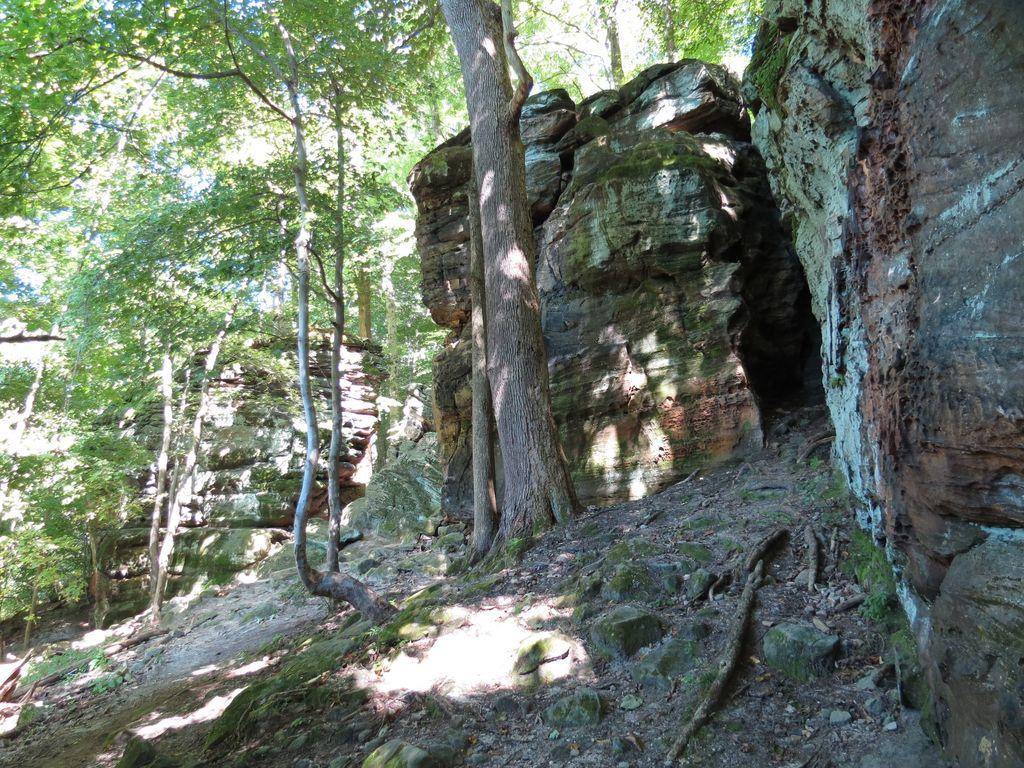What type of natural elements can be seen in the image? There are rocks in the image. What can be seen in the background of the image? There are trees and the sky visible in the background of the image. What type of jelly can be seen on the rocks in the image? There is no jelly present on the rocks in the image. Can you read any writing on the rocks in the image? There is no writing visible on the rocks in the image. 